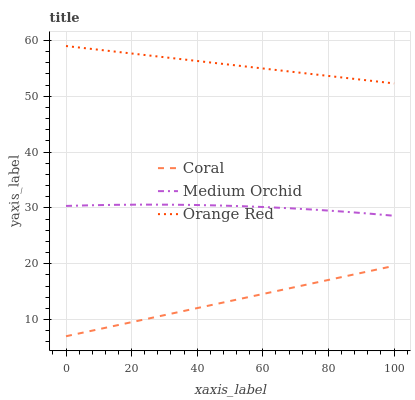Does Medium Orchid have the minimum area under the curve?
Answer yes or no. No. Does Medium Orchid have the maximum area under the curve?
Answer yes or no. No. Is Medium Orchid the smoothest?
Answer yes or no. No. Is Orange Red the roughest?
Answer yes or no. No. Does Medium Orchid have the lowest value?
Answer yes or no. No. Does Medium Orchid have the highest value?
Answer yes or no. No. Is Coral less than Medium Orchid?
Answer yes or no. Yes. Is Medium Orchid greater than Coral?
Answer yes or no. Yes. Does Coral intersect Medium Orchid?
Answer yes or no. No. 